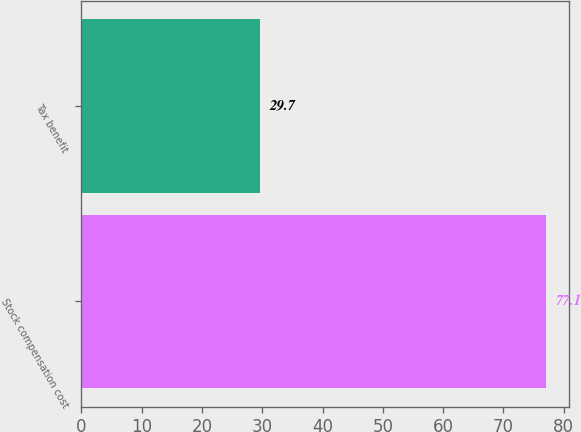Convert chart to OTSL. <chart><loc_0><loc_0><loc_500><loc_500><bar_chart><fcel>Stock compensation cost<fcel>Tax benefit<nl><fcel>77.1<fcel>29.7<nl></chart> 